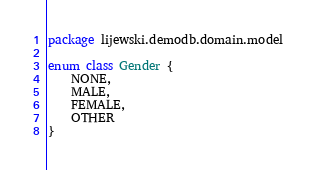<code> <loc_0><loc_0><loc_500><loc_500><_Kotlin_>package lijewski.demodb.domain.model

enum class Gender {
    NONE,
    MALE,
    FEMALE,
    OTHER
}
</code> 